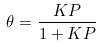Convert formula to latex. <formula><loc_0><loc_0><loc_500><loc_500>\theta = \frac { K P } { 1 + K P }</formula> 